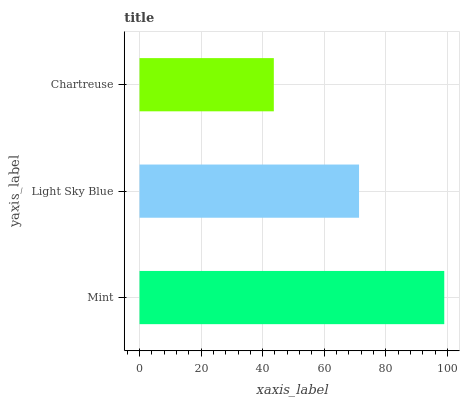Is Chartreuse the minimum?
Answer yes or no. Yes. Is Mint the maximum?
Answer yes or no. Yes. Is Light Sky Blue the minimum?
Answer yes or no. No. Is Light Sky Blue the maximum?
Answer yes or no. No. Is Mint greater than Light Sky Blue?
Answer yes or no. Yes. Is Light Sky Blue less than Mint?
Answer yes or no. Yes. Is Light Sky Blue greater than Mint?
Answer yes or no. No. Is Mint less than Light Sky Blue?
Answer yes or no. No. Is Light Sky Blue the high median?
Answer yes or no. Yes. Is Light Sky Blue the low median?
Answer yes or no. Yes. Is Mint the high median?
Answer yes or no. No. Is Chartreuse the low median?
Answer yes or no. No. 